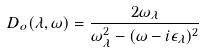Convert formula to latex. <formula><loc_0><loc_0><loc_500><loc_500>D _ { o } ( \lambda , \omega ) = \frac { 2 \omega _ { \lambda } } { \omega _ { \lambda } ^ { 2 } - ( \omega - i \epsilon _ { \lambda } ) ^ { 2 } }</formula> 